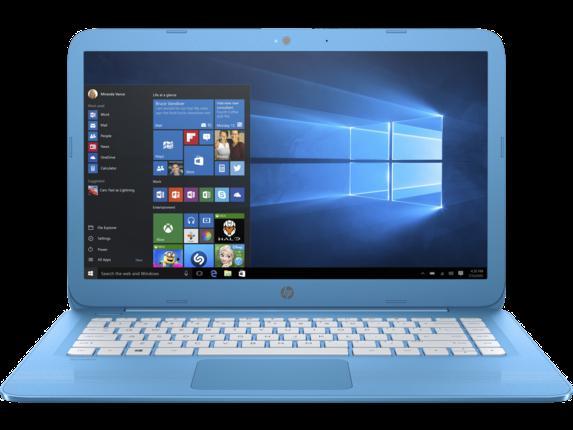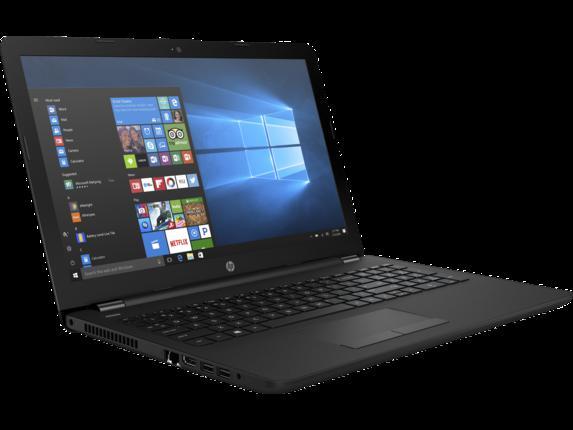The first image is the image on the left, the second image is the image on the right. Considering the images on both sides, is "The open laptop on the left is displayed head-on, while the one on the right is turned at an angle." valid? Answer yes or no. Yes. The first image is the image on the left, the second image is the image on the right. Examine the images to the left and right. Is the description "Every single laptop appears to be powered on right now." accurate? Answer yes or no. Yes. 